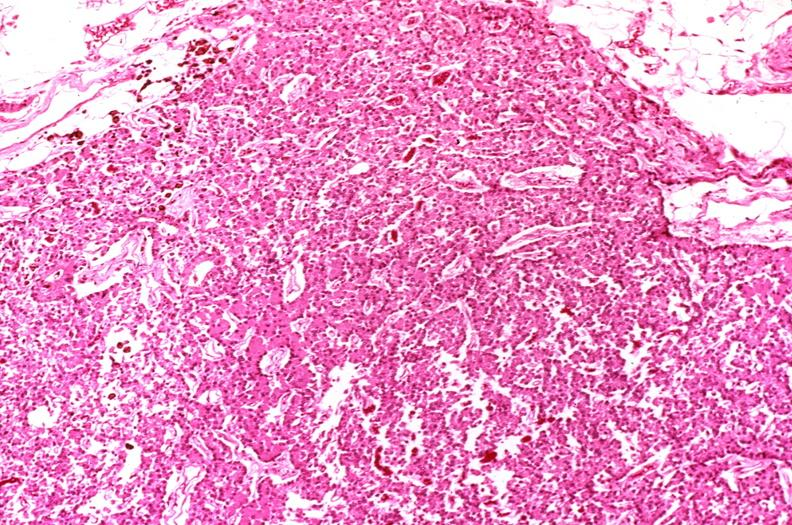what is present?
Answer the question using a single word or phrase. Endocrine 